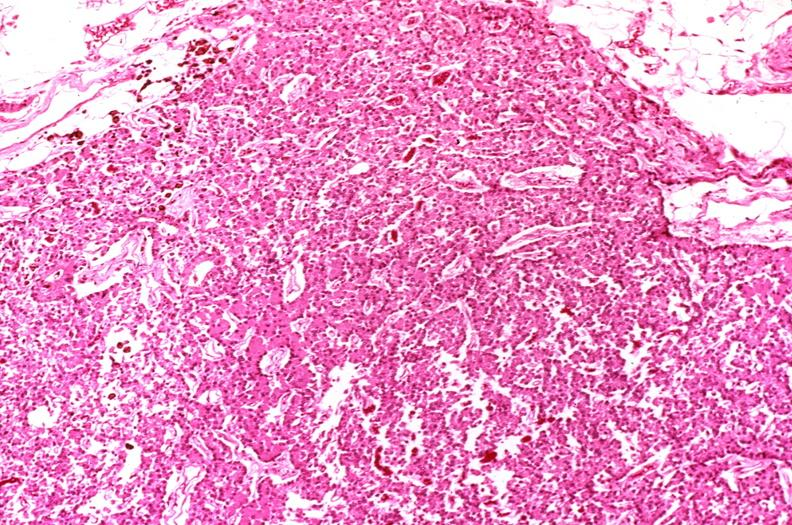what is present?
Answer the question using a single word or phrase. Endocrine 